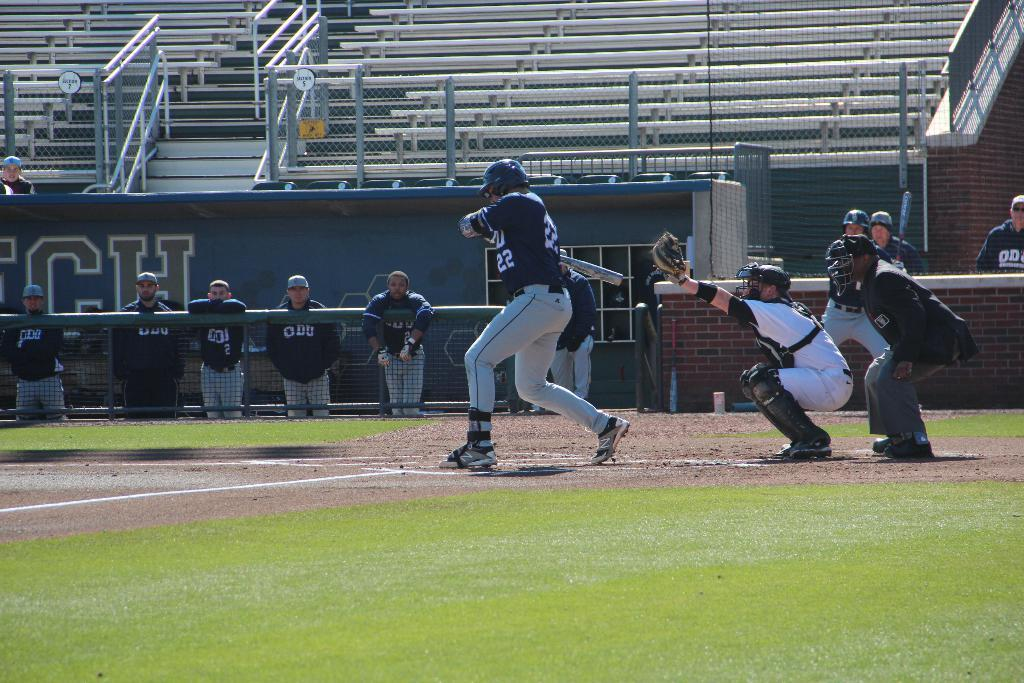<image>
Share a concise interpretation of the image provided. The player at bat is wearing jersey number 22 